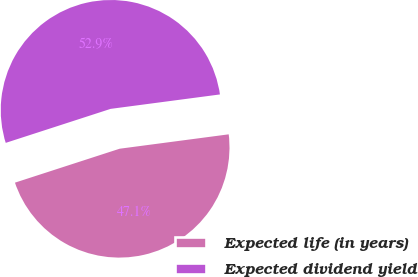Convert chart. <chart><loc_0><loc_0><loc_500><loc_500><pie_chart><fcel>Expected life (in years)<fcel>Expected dividend yield<nl><fcel>47.1%<fcel>52.9%<nl></chart> 